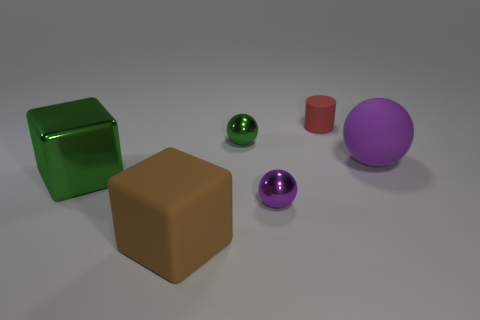There is a matte cylinder; does it have the same color as the big cube behind the tiny purple metallic ball?
Your answer should be very brief. No. How many tiny purple objects are there?
Your response must be concise. 1. How many objects are either purple things or red objects?
Make the answer very short. 3. The shiny sphere that is the same color as the rubber sphere is what size?
Offer a very short reply. Small. Are there any tiny things right of the tiny purple ball?
Your answer should be very brief. Yes. Is the number of rubber objects that are left of the red object greater than the number of small green shiny things that are on the right side of the small green object?
Provide a succinct answer. Yes. There is another thing that is the same shape as the brown matte thing; what size is it?
Your response must be concise. Large. What number of cylinders are either tiny brown rubber things or green metallic objects?
Your answer should be very brief. 0. Are there fewer brown blocks on the right side of the small purple sphere than things in front of the cylinder?
Your answer should be very brief. Yes. How many things are either large cubes that are behind the purple metallic ball or purple matte objects?
Your answer should be compact. 2. 